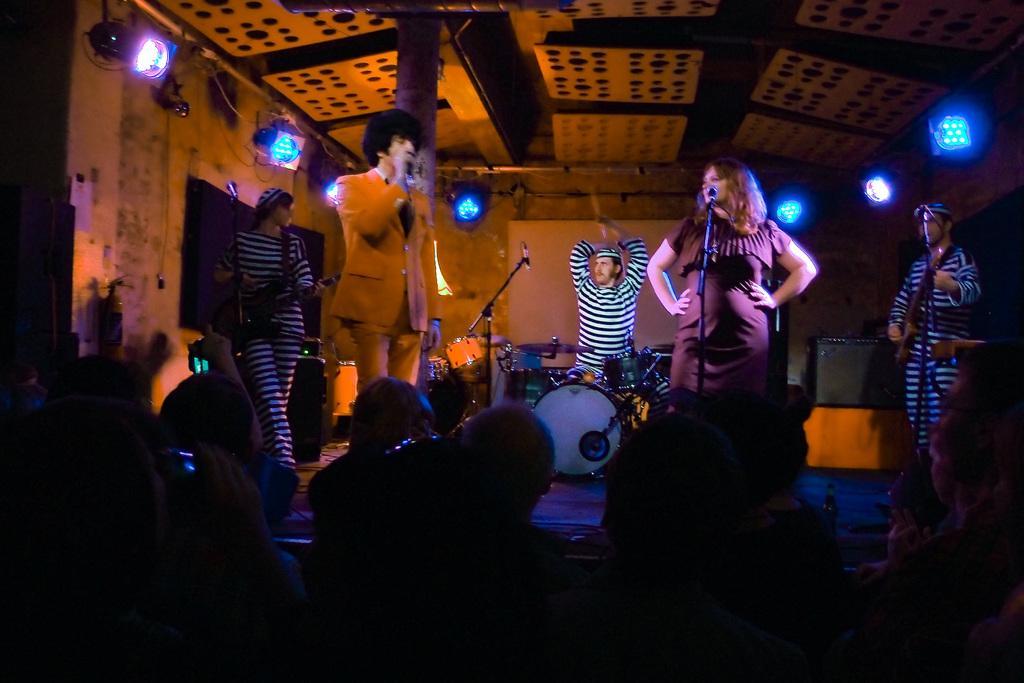Please provide a concise description of this image. This picture is clicked in the musical concert. At the bottom of the picture, we see people are sitting on the chairs. In front of them, we see five people are standing. The man in orange blazer is singing the song on the microphone. Beside him, the woman is standing. In front of her, we see a microphone. Behind them, we see the musical instruments and a man is standing behind that. On either side of the picture, we see two people are playing the guitars. In the background, we see a wall and the lights. At the top, we see the ceiling of the room. 